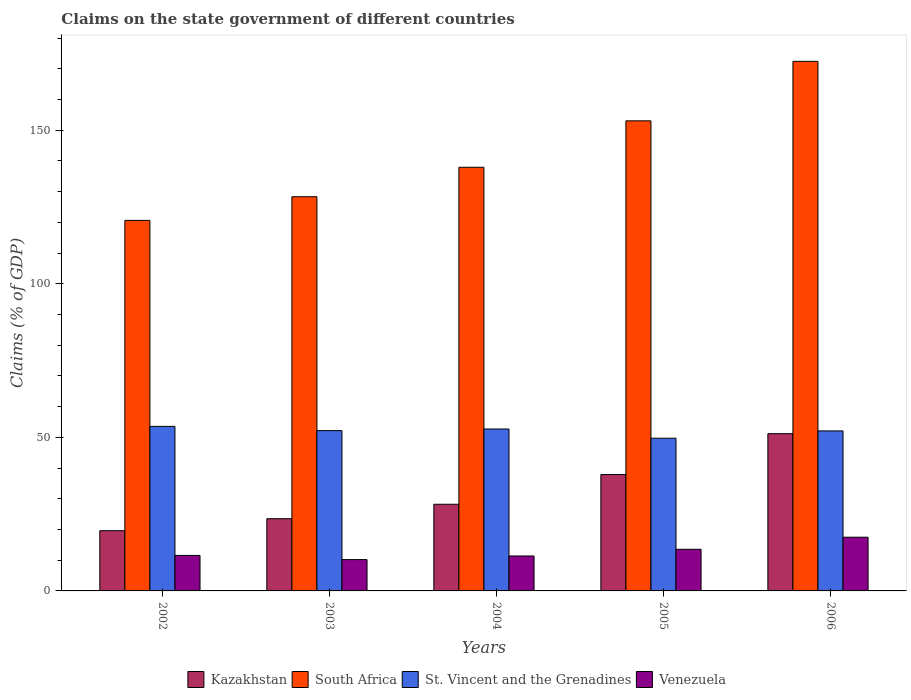How many different coloured bars are there?
Your answer should be compact. 4. Are the number of bars per tick equal to the number of legend labels?
Your answer should be compact. Yes. How many bars are there on the 1st tick from the left?
Make the answer very short. 4. What is the percentage of GDP claimed on the state government in Kazakhstan in 2002?
Make the answer very short. 19.61. Across all years, what is the maximum percentage of GDP claimed on the state government in Venezuela?
Ensure brevity in your answer.  17.49. Across all years, what is the minimum percentage of GDP claimed on the state government in Venezuela?
Provide a short and direct response. 10.2. What is the total percentage of GDP claimed on the state government in Venezuela in the graph?
Provide a short and direct response. 64.17. What is the difference between the percentage of GDP claimed on the state government in Kazakhstan in 2004 and that in 2006?
Provide a short and direct response. -22.98. What is the difference between the percentage of GDP claimed on the state government in Venezuela in 2003 and the percentage of GDP claimed on the state government in St. Vincent and the Grenadines in 2006?
Offer a very short reply. -41.9. What is the average percentage of GDP claimed on the state government in St. Vincent and the Grenadines per year?
Offer a terse response. 52.06. In the year 2005, what is the difference between the percentage of GDP claimed on the state government in Venezuela and percentage of GDP claimed on the state government in St. Vincent and the Grenadines?
Make the answer very short. -36.17. In how many years, is the percentage of GDP claimed on the state government in Venezuela greater than 10 %?
Give a very brief answer. 5. What is the ratio of the percentage of GDP claimed on the state government in South Africa in 2002 to that in 2005?
Give a very brief answer. 0.79. Is the percentage of GDP claimed on the state government in South Africa in 2004 less than that in 2006?
Provide a short and direct response. Yes. What is the difference between the highest and the second highest percentage of GDP claimed on the state government in Venezuela?
Give a very brief answer. 3.93. What is the difference between the highest and the lowest percentage of GDP claimed on the state government in Venezuela?
Keep it short and to the point. 7.29. In how many years, is the percentage of GDP claimed on the state government in Kazakhstan greater than the average percentage of GDP claimed on the state government in Kazakhstan taken over all years?
Your answer should be very brief. 2. What does the 2nd bar from the left in 2005 represents?
Provide a short and direct response. South Africa. What does the 1st bar from the right in 2003 represents?
Offer a very short reply. Venezuela. How many bars are there?
Keep it short and to the point. 20. Are the values on the major ticks of Y-axis written in scientific E-notation?
Offer a terse response. No. Does the graph contain any zero values?
Your answer should be very brief. No. Does the graph contain grids?
Give a very brief answer. No. What is the title of the graph?
Make the answer very short. Claims on the state government of different countries. Does "Mauritius" appear as one of the legend labels in the graph?
Keep it short and to the point. No. What is the label or title of the X-axis?
Your answer should be very brief. Years. What is the label or title of the Y-axis?
Give a very brief answer. Claims (% of GDP). What is the Claims (% of GDP) in Kazakhstan in 2002?
Provide a short and direct response. 19.61. What is the Claims (% of GDP) of South Africa in 2002?
Provide a succinct answer. 120.63. What is the Claims (% of GDP) in St. Vincent and the Grenadines in 2002?
Ensure brevity in your answer.  53.56. What is the Claims (% of GDP) in Venezuela in 2002?
Your response must be concise. 11.56. What is the Claims (% of GDP) of Kazakhstan in 2003?
Give a very brief answer. 23.51. What is the Claims (% of GDP) in South Africa in 2003?
Your answer should be compact. 128.34. What is the Claims (% of GDP) of St. Vincent and the Grenadines in 2003?
Give a very brief answer. 52.19. What is the Claims (% of GDP) in Venezuela in 2003?
Make the answer very short. 10.2. What is the Claims (% of GDP) of Kazakhstan in 2004?
Offer a terse response. 28.21. What is the Claims (% of GDP) of South Africa in 2004?
Keep it short and to the point. 137.93. What is the Claims (% of GDP) of St. Vincent and the Grenadines in 2004?
Offer a terse response. 52.72. What is the Claims (% of GDP) in Venezuela in 2004?
Provide a short and direct response. 11.38. What is the Claims (% of GDP) in Kazakhstan in 2005?
Provide a short and direct response. 37.89. What is the Claims (% of GDP) of South Africa in 2005?
Provide a short and direct response. 153.04. What is the Claims (% of GDP) of St. Vincent and the Grenadines in 2005?
Your response must be concise. 49.72. What is the Claims (% of GDP) in Venezuela in 2005?
Your answer should be very brief. 13.55. What is the Claims (% of GDP) in Kazakhstan in 2006?
Your answer should be very brief. 51.2. What is the Claims (% of GDP) in South Africa in 2006?
Offer a terse response. 172.41. What is the Claims (% of GDP) of St. Vincent and the Grenadines in 2006?
Your response must be concise. 52.09. What is the Claims (% of GDP) of Venezuela in 2006?
Provide a short and direct response. 17.49. Across all years, what is the maximum Claims (% of GDP) of Kazakhstan?
Provide a succinct answer. 51.2. Across all years, what is the maximum Claims (% of GDP) in South Africa?
Provide a succinct answer. 172.41. Across all years, what is the maximum Claims (% of GDP) in St. Vincent and the Grenadines?
Keep it short and to the point. 53.56. Across all years, what is the maximum Claims (% of GDP) of Venezuela?
Make the answer very short. 17.49. Across all years, what is the minimum Claims (% of GDP) in Kazakhstan?
Give a very brief answer. 19.61. Across all years, what is the minimum Claims (% of GDP) in South Africa?
Make the answer very short. 120.63. Across all years, what is the minimum Claims (% of GDP) in St. Vincent and the Grenadines?
Offer a terse response. 49.72. Across all years, what is the minimum Claims (% of GDP) in Venezuela?
Provide a succinct answer. 10.2. What is the total Claims (% of GDP) of Kazakhstan in the graph?
Give a very brief answer. 160.42. What is the total Claims (% of GDP) in South Africa in the graph?
Make the answer very short. 712.35. What is the total Claims (% of GDP) of St. Vincent and the Grenadines in the graph?
Give a very brief answer. 260.28. What is the total Claims (% of GDP) in Venezuela in the graph?
Your answer should be compact. 64.17. What is the difference between the Claims (% of GDP) in Kazakhstan in 2002 and that in 2003?
Ensure brevity in your answer.  -3.9. What is the difference between the Claims (% of GDP) in South Africa in 2002 and that in 2003?
Offer a very short reply. -7.7. What is the difference between the Claims (% of GDP) of St. Vincent and the Grenadines in 2002 and that in 2003?
Give a very brief answer. 1.37. What is the difference between the Claims (% of GDP) in Venezuela in 2002 and that in 2003?
Make the answer very short. 1.36. What is the difference between the Claims (% of GDP) in Kazakhstan in 2002 and that in 2004?
Provide a succinct answer. -8.61. What is the difference between the Claims (% of GDP) of South Africa in 2002 and that in 2004?
Offer a terse response. -17.29. What is the difference between the Claims (% of GDP) in St. Vincent and the Grenadines in 2002 and that in 2004?
Offer a very short reply. 0.84. What is the difference between the Claims (% of GDP) of Venezuela in 2002 and that in 2004?
Give a very brief answer. 0.18. What is the difference between the Claims (% of GDP) of Kazakhstan in 2002 and that in 2005?
Provide a succinct answer. -18.28. What is the difference between the Claims (% of GDP) of South Africa in 2002 and that in 2005?
Make the answer very short. -32.41. What is the difference between the Claims (% of GDP) in St. Vincent and the Grenadines in 2002 and that in 2005?
Your response must be concise. 3.84. What is the difference between the Claims (% of GDP) of Venezuela in 2002 and that in 2005?
Offer a very short reply. -2. What is the difference between the Claims (% of GDP) of Kazakhstan in 2002 and that in 2006?
Provide a succinct answer. -31.59. What is the difference between the Claims (% of GDP) in South Africa in 2002 and that in 2006?
Offer a terse response. -51.77. What is the difference between the Claims (% of GDP) in St. Vincent and the Grenadines in 2002 and that in 2006?
Provide a short and direct response. 1.47. What is the difference between the Claims (% of GDP) of Venezuela in 2002 and that in 2006?
Offer a terse response. -5.93. What is the difference between the Claims (% of GDP) of Kazakhstan in 2003 and that in 2004?
Provide a succinct answer. -4.7. What is the difference between the Claims (% of GDP) of South Africa in 2003 and that in 2004?
Make the answer very short. -9.59. What is the difference between the Claims (% of GDP) in St. Vincent and the Grenadines in 2003 and that in 2004?
Keep it short and to the point. -0.53. What is the difference between the Claims (% of GDP) of Venezuela in 2003 and that in 2004?
Your answer should be compact. -1.18. What is the difference between the Claims (% of GDP) in Kazakhstan in 2003 and that in 2005?
Your answer should be very brief. -14.38. What is the difference between the Claims (% of GDP) in South Africa in 2003 and that in 2005?
Make the answer very short. -24.7. What is the difference between the Claims (% of GDP) of St. Vincent and the Grenadines in 2003 and that in 2005?
Your answer should be compact. 2.47. What is the difference between the Claims (% of GDP) of Venezuela in 2003 and that in 2005?
Your response must be concise. -3.36. What is the difference between the Claims (% of GDP) of Kazakhstan in 2003 and that in 2006?
Offer a very short reply. -27.69. What is the difference between the Claims (% of GDP) of South Africa in 2003 and that in 2006?
Keep it short and to the point. -44.07. What is the difference between the Claims (% of GDP) of St. Vincent and the Grenadines in 2003 and that in 2006?
Offer a terse response. 0.1. What is the difference between the Claims (% of GDP) in Venezuela in 2003 and that in 2006?
Provide a short and direct response. -7.29. What is the difference between the Claims (% of GDP) of Kazakhstan in 2004 and that in 2005?
Offer a very short reply. -9.67. What is the difference between the Claims (% of GDP) of South Africa in 2004 and that in 2005?
Make the answer very short. -15.12. What is the difference between the Claims (% of GDP) of St. Vincent and the Grenadines in 2004 and that in 2005?
Provide a succinct answer. 3. What is the difference between the Claims (% of GDP) in Venezuela in 2004 and that in 2005?
Offer a terse response. -2.18. What is the difference between the Claims (% of GDP) of Kazakhstan in 2004 and that in 2006?
Make the answer very short. -22.98. What is the difference between the Claims (% of GDP) of South Africa in 2004 and that in 2006?
Offer a terse response. -34.48. What is the difference between the Claims (% of GDP) of St. Vincent and the Grenadines in 2004 and that in 2006?
Give a very brief answer. 0.63. What is the difference between the Claims (% of GDP) in Venezuela in 2004 and that in 2006?
Give a very brief answer. -6.11. What is the difference between the Claims (% of GDP) of Kazakhstan in 2005 and that in 2006?
Ensure brevity in your answer.  -13.31. What is the difference between the Claims (% of GDP) in South Africa in 2005 and that in 2006?
Make the answer very short. -19.37. What is the difference between the Claims (% of GDP) of St. Vincent and the Grenadines in 2005 and that in 2006?
Ensure brevity in your answer.  -2.37. What is the difference between the Claims (% of GDP) in Venezuela in 2005 and that in 2006?
Keep it short and to the point. -3.93. What is the difference between the Claims (% of GDP) in Kazakhstan in 2002 and the Claims (% of GDP) in South Africa in 2003?
Keep it short and to the point. -108.73. What is the difference between the Claims (% of GDP) of Kazakhstan in 2002 and the Claims (% of GDP) of St. Vincent and the Grenadines in 2003?
Offer a terse response. -32.58. What is the difference between the Claims (% of GDP) of Kazakhstan in 2002 and the Claims (% of GDP) of Venezuela in 2003?
Your response must be concise. 9.41. What is the difference between the Claims (% of GDP) in South Africa in 2002 and the Claims (% of GDP) in St. Vincent and the Grenadines in 2003?
Ensure brevity in your answer.  68.44. What is the difference between the Claims (% of GDP) of South Africa in 2002 and the Claims (% of GDP) of Venezuela in 2003?
Ensure brevity in your answer.  110.44. What is the difference between the Claims (% of GDP) in St. Vincent and the Grenadines in 2002 and the Claims (% of GDP) in Venezuela in 2003?
Provide a succinct answer. 43.37. What is the difference between the Claims (% of GDP) in Kazakhstan in 2002 and the Claims (% of GDP) in South Africa in 2004?
Give a very brief answer. -118.32. What is the difference between the Claims (% of GDP) of Kazakhstan in 2002 and the Claims (% of GDP) of St. Vincent and the Grenadines in 2004?
Your answer should be very brief. -33.11. What is the difference between the Claims (% of GDP) of Kazakhstan in 2002 and the Claims (% of GDP) of Venezuela in 2004?
Ensure brevity in your answer.  8.23. What is the difference between the Claims (% of GDP) of South Africa in 2002 and the Claims (% of GDP) of St. Vincent and the Grenadines in 2004?
Keep it short and to the point. 67.92. What is the difference between the Claims (% of GDP) of South Africa in 2002 and the Claims (% of GDP) of Venezuela in 2004?
Provide a succinct answer. 109.26. What is the difference between the Claims (% of GDP) in St. Vincent and the Grenadines in 2002 and the Claims (% of GDP) in Venezuela in 2004?
Give a very brief answer. 42.19. What is the difference between the Claims (% of GDP) of Kazakhstan in 2002 and the Claims (% of GDP) of South Africa in 2005?
Provide a succinct answer. -133.43. What is the difference between the Claims (% of GDP) in Kazakhstan in 2002 and the Claims (% of GDP) in St. Vincent and the Grenadines in 2005?
Keep it short and to the point. -30.11. What is the difference between the Claims (% of GDP) of Kazakhstan in 2002 and the Claims (% of GDP) of Venezuela in 2005?
Your answer should be very brief. 6.06. What is the difference between the Claims (% of GDP) of South Africa in 2002 and the Claims (% of GDP) of St. Vincent and the Grenadines in 2005?
Provide a succinct answer. 70.92. What is the difference between the Claims (% of GDP) of South Africa in 2002 and the Claims (% of GDP) of Venezuela in 2005?
Your answer should be compact. 107.08. What is the difference between the Claims (% of GDP) of St. Vincent and the Grenadines in 2002 and the Claims (% of GDP) of Venezuela in 2005?
Provide a succinct answer. 40.01. What is the difference between the Claims (% of GDP) in Kazakhstan in 2002 and the Claims (% of GDP) in South Africa in 2006?
Keep it short and to the point. -152.8. What is the difference between the Claims (% of GDP) of Kazakhstan in 2002 and the Claims (% of GDP) of St. Vincent and the Grenadines in 2006?
Your response must be concise. -32.48. What is the difference between the Claims (% of GDP) in Kazakhstan in 2002 and the Claims (% of GDP) in Venezuela in 2006?
Keep it short and to the point. 2.12. What is the difference between the Claims (% of GDP) of South Africa in 2002 and the Claims (% of GDP) of St. Vincent and the Grenadines in 2006?
Your response must be concise. 68.54. What is the difference between the Claims (% of GDP) in South Africa in 2002 and the Claims (% of GDP) in Venezuela in 2006?
Provide a succinct answer. 103.15. What is the difference between the Claims (% of GDP) of St. Vincent and the Grenadines in 2002 and the Claims (% of GDP) of Venezuela in 2006?
Your response must be concise. 36.07. What is the difference between the Claims (% of GDP) of Kazakhstan in 2003 and the Claims (% of GDP) of South Africa in 2004?
Offer a very short reply. -114.41. What is the difference between the Claims (% of GDP) in Kazakhstan in 2003 and the Claims (% of GDP) in St. Vincent and the Grenadines in 2004?
Keep it short and to the point. -29.21. What is the difference between the Claims (% of GDP) in Kazakhstan in 2003 and the Claims (% of GDP) in Venezuela in 2004?
Offer a terse response. 12.14. What is the difference between the Claims (% of GDP) in South Africa in 2003 and the Claims (% of GDP) in St. Vincent and the Grenadines in 2004?
Give a very brief answer. 75.62. What is the difference between the Claims (% of GDP) of South Africa in 2003 and the Claims (% of GDP) of Venezuela in 2004?
Your answer should be very brief. 116.96. What is the difference between the Claims (% of GDP) of St. Vincent and the Grenadines in 2003 and the Claims (% of GDP) of Venezuela in 2004?
Keep it short and to the point. 40.82. What is the difference between the Claims (% of GDP) in Kazakhstan in 2003 and the Claims (% of GDP) in South Africa in 2005?
Your answer should be compact. -129.53. What is the difference between the Claims (% of GDP) of Kazakhstan in 2003 and the Claims (% of GDP) of St. Vincent and the Grenadines in 2005?
Your answer should be compact. -26.21. What is the difference between the Claims (% of GDP) of Kazakhstan in 2003 and the Claims (% of GDP) of Venezuela in 2005?
Your answer should be very brief. 9.96. What is the difference between the Claims (% of GDP) in South Africa in 2003 and the Claims (% of GDP) in St. Vincent and the Grenadines in 2005?
Offer a terse response. 78.62. What is the difference between the Claims (% of GDP) in South Africa in 2003 and the Claims (% of GDP) in Venezuela in 2005?
Give a very brief answer. 114.79. What is the difference between the Claims (% of GDP) of St. Vincent and the Grenadines in 2003 and the Claims (% of GDP) of Venezuela in 2005?
Offer a very short reply. 38.64. What is the difference between the Claims (% of GDP) in Kazakhstan in 2003 and the Claims (% of GDP) in South Africa in 2006?
Keep it short and to the point. -148.9. What is the difference between the Claims (% of GDP) in Kazakhstan in 2003 and the Claims (% of GDP) in St. Vincent and the Grenadines in 2006?
Make the answer very short. -28.58. What is the difference between the Claims (% of GDP) of Kazakhstan in 2003 and the Claims (% of GDP) of Venezuela in 2006?
Provide a short and direct response. 6.02. What is the difference between the Claims (% of GDP) of South Africa in 2003 and the Claims (% of GDP) of St. Vincent and the Grenadines in 2006?
Keep it short and to the point. 76.25. What is the difference between the Claims (% of GDP) in South Africa in 2003 and the Claims (% of GDP) in Venezuela in 2006?
Offer a terse response. 110.85. What is the difference between the Claims (% of GDP) of St. Vincent and the Grenadines in 2003 and the Claims (% of GDP) of Venezuela in 2006?
Offer a very short reply. 34.7. What is the difference between the Claims (% of GDP) of Kazakhstan in 2004 and the Claims (% of GDP) of South Africa in 2005?
Offer a very short reply. -124.83. What is the difference between the Claims (% of GDP) of Kazakhstan in 2004 and the Claims (% of GDP) of St. Vincent and the Grenadines in 2005?
Keep it short and to the point. -21.5. What is the difference between the Claims (% of GDP) of Kazakhstan in 2004 and the Claims (% of GDP) of Venezuela in 2005?
Give a very brief answer. 14.66. What is the difference between the Claims (% of GDP) in South Africa in 2004 and the Claims (% of GDP) in St. Vincent and the Grenadines in 2005?
Keep it short and to the point. 88.21. What is the difference between the Claims (% of GDP) in South Africa in 2004 and the Claims (% of GDP) in Venezuela in 2005?
Provide a succinct answer. 124.37. What is the difference between the Claims (% of GDP) in St. Vincent and the Grenadines in 2004 and the Claims (% of GDP) in Venezuela in 2005?
Ensure brevity in your answer.  39.17. What is the difference between the Claims (% of GDP) in Kazakhstan in 2004 and the Claims (% of GDP) in South Africa in 2006?
Your answer should be very brief. -144.19. What is the difference between the Claims (% of GDP) in Kazakhstan in 2004 and the Claims (% of GDP) in St. Vincent and the Grenadines in 2006?
Ensure brevity in your answer.  -23.88. What is the difference between the Claims (% of GDP) of Kazakhstan in 2004 and the Claims (% of GDP) of Venezuela in 2006?
Ensure brevity in your answer.  10.73. What is the difference between the Claims (% of GDP) of South Africa in 2004 and the Claims (% of GDP) of St. Vincent and the Grenadines in 2006?
Provide a succinct answer. 85.83. What is the difference between the Claims (% of GDP) of South Africa in 2004 and the Claims (% of GDP) of Venezuela in 2006?
Provide a succinct answer. 120.44. What is the difference between the Claims (% of GDP) of St. Vincent and the Grenadines in 2004 and the Claims (% of GDP) of Venezuela in 2006?
Keep it short and to the point. 35.23. What is the difference between the Claims (% of GDP) in Kazakhstan in 2005 and the Claims (% of GDP) in South Africa in 2006?
Your answer should be compact. -134.52. What is the difference between the Claims (% of GDP) of Kazakhstan in 2005 and the Claims (% of GDP) of St. Vincent and the Grenadines in 2006?
Offer a very short reply. -14.21. What is the difference between the Claims (% of GDP) of Kazakhstan in 2005 and the Claims (% of GDP) of Venezuela in 2006?
Offer a terse response. 20.4. What is the difference between the Claims (% of GDP) of South Africa in 2005 and the Claims (% of GDP) of St. Vincent and the Grenadines in 2006?
Your response must be concise. 100.95. What is the difference between the Claims (% of GDP) in South Africa in 2005 and the Claims (% of GDP) in Venezuela in 2006?
Provide a short and direct response. 135.56. What is the difference between the Claims (% of GDP) in St. Vincent and the Grenadines in 2005 and the Claims (% of GDP) in Venezuela in 2006?
Keep it short and to the point. 32.23. What is the average Claims (% of GDP) of Kazakhstan per year?
Make the answer very short. 32.08. What is the average Claims (% of GDP) in South Africa per year?
Provide a succinct answer. 142.47. What is the average Claims (% of GDP) in St. Vincent and the Grenadines per year?
Your answer should be very brief. 52.06. What is the average Claims (% of GDP) of Venezuela per year?
Your answer should be compact. 12.83. In the year 2002, what is the difference between the Claims (% of GDP) of Kazakhstan and Claims (% of GDP) of South Africa?
Offer a terse response. -101.03. In the year 2002, what is the difference between the Claims (% of GDP) of Kazakhstan and Claims (% of GDP) of St. Vincent and the Grenadines?
Your answer should be very brief. -33.95. In the year 2002, what is the difference between the Claims (% of GDP) in Kazakhstan and Claims (% of GDP) in Venezuela?
Your answer should be very brief. 8.05. In the year 2002, what is the difference between the Claims (% of GDP) of South Africa and Claims (% of GDP) of St. Vincent and the Grenadines?
Give a very brief answer. 67.07. In the year 2002, what is the difference between the Claims (% of GDP) of South Africa and Claims (% of GDP) of Venezuela?
Your answer should be compact. 109.08. In the year 2002, what is the difference between the Claims (% of GDP) in St. Vincent and the Grenadines and Claims (% of GDP) in Venezuela?
Your answer should be very brief. 42. In the year 2003, what is the difference between the Claims (% of GDP) in Kazakhstan and Claims (% of GDP) in South Africa?
Keep it short and to the point. -104.83. In the year 2003, what is the difference between the Claims (% of GDP) in Kazakhstan and Claims (% of GDP) in St. Vincent and the Grenadines?
Provide a succinct answer. -28.68. In the year 2003, what is the difference between the Claims (% of GDP) of Kazakhstan and Claims (% of GDP) of Venezuela?
Your response must be concise. 13.32. In the year 2003, what is the difference between the Claims (% of GDP) in South Africa and Claims (% of GDP) in St. Vincent and the Grenadines?
Your answer should be very brief. 76.15. In the year 2003, what is the difference between the Claims (% of GDP) in South Africa and Claims (% of GDP) in Venezuela?
Provide a short and direct response. 118.14. In the year 2003, what is the difference between the Claims (% of GDP) of St. Vincent and the Grenadines and Claims (% of GDP) of Venezuela?
Make the answer very short. 42. In the year 2004, what is the difference between the Claims (% of GDP) in Kazakhstan and Claims (% of GDP) in South Africa?
Your response must be concise. -109.71. In the year 2004, what is the difference between the Claims (% of GDP) of Kazakhstan and Claims (% of GDP) of St. Vincent and the Grenadines?
Make the answer very short. -24.5. In the year 2004, what is the difference between the Claims (% of GDP) of Kazakhstan and Claims (% of GDP) of Venezuela?
Your answer should be compact. 16.84. In the year 2004, what is the difference between the Claims (% of GDP) in South Africa and Claims (% of GDP) in St. Vincent and the Grenadines?
Provide a succinct answer. 85.21. In the year 2004, what is the difference between the Claims (% of GDP) in South Africa and Claims (% of GDP) in Venezuela?
Offer a very short reply. 126.55. In the year 2004, what is the difference between the Claims (% of GDP) in St. Vincent and the Grenadines and Claims (% of GDP) in Venezuela?
Keep it short and to the point. 41.34. In the year 2005, what is the difference between the Claims (% of GDP) of Kazakhstan and Claims (% of GDP) of South Africa?
Your answer should be compact. -115.16. In the year 2005, what is the difference between the Claims (% of GDP) in Kazakhstan and Claims (% of GDP) in St. Vincent and the Grenadines?
Keep it short and to the point. -11.83. In the year 2005, what is the difference between the Claims (% of GDP) in Kazakhstan and Claims (% of GDP) in Venezuela?
Your answer should be compact. 24.34. In the year 2005, what is the difference between the Claims (% of GDP) in South Africa and Claims (% of GDP) in St. Vincent and the Grenadines?
Offer a terse response. 103.32. In the year 2005, what is the difference between the Claims (% of GDP) of South Africa and Claims (% of GDP) of Venezuela?
Your answer should be compact. 139.49. In the year 2005, what is the difference between the Claims (% of GDP) in St. Vincent and the Grenadines and Claims (% of GDP) in Venezuela?
Your answer should be compact. 36.17. In the year 2006, what is the difference between the Claims (% of GDP) of Kazakhstan and Claims (% of GDP) of South Africa?
Your answer should be compact. -121.21. In the year 2006, what is the difference between the Claims (% of GDP) in Kazakhstan and Claims (% of GDP) in St. Vincent and the Grenadines?
Make the answer very short. -0.89. In the year 2006, what is the difference between the Claims (% of GDP) of Kazakhstan and Claims (% of GDP) of Venezuela?
Keep it short and to the point. 33.71. In the year 2006, what is the difference between the Claims (% of GDP) in South Africa and Claims (% of GDP) in St. Vincent and the Grenadines?
Ensure brevity in your answer.  120.32. In the year 2006, what is the difference between the Claims (% of GDP) of South Africa and Claims (% of GDP) of Venezuela?
Provide a succinct answer. 154.92. In the year 2006, what is the difference between the Claims (% of GDP) in St. Vincent and the Grenadines and Claims (% of GDP) in Venezuela?
Your answer should be very brief. 34.61. What is the ratio of the Claims (% of GDP) in Kazakhstan in 2002 to that in 2003?
Provide a short and direct response. 0.83. What is the ratio of the Claims (% of GDP) of St. Vincent and the Grenadines in 2002 to that in 2003?
Make the answer very short. 1.03. What is the ratio of the Claims (% of GDP) in Venezuela in 2002 to that in 2003?
Provide a short and direct response. 1.13. What is the ratio of the Claims (% of GDP) in Kazakhstan in 2002 to that in 2004?
Give a very brief answer. 0.69. What is the ratio of the Claims (% of GDP) in South Africa in 2002 to that in 2004?
Your answer should be very brief. 0.87. What is the ratio of the Claims (% of GDP) of St. Vincent and the Grenadines in 2002 to that in 2004?
Ensure brevity in your answer.  1.02. What is the ratio of the Claims (% of GDP) of Venezuela in 2002 to that in 2004?
Your response must be concise. 1.02. What is the ratio of the Claims (% of GDP) in Kazakhstan in 2002 to that in 2005?
Provide a succinct answer. 0.52. What is the ratio of the Claims (% of GDP) in South Africa in 2002 to that in 2005?
Offer a very short reply. 0.79. What is the ratio of the Claims (% of GDP) in St. Vincent and the Grenadines in 2002 to that in 2005?
Offer a terse response. 1.08. What is the ratio of the Claims (% of GDP) in Venezuela in 2002 to that in 2005?
Your response must be concise. 0.85. What is the ratio of the Claims (% of GDP) in Kazakhstan in 2002 to that in 2006?
Give a very brief answer. 0.38. What is the ratio of the Claims (% of GDP) of South Africa in 2002 to that in 2006?
Provide a succinct answer. 0.7. What is the ratio of the Claims (% of GDP) of St. Vincent and the Grenadines in 2002 to that in 2006?
Offer a terse response. 1.03. What is the ratio of the Claims (% of GDP) in Venezuela in 2002 to that in 2006?
Your answer should be very brief. 0.66. What is the ratio of the Claims (% of GDP) of Kazakhstan in 2003 to that in 2004?
Your answer should be very brief. 0.83. What is the ratio of the Claims (% of GDP) of South Africa in 2003 to that in 2004?
Make the answer very short. 0.93. What is the ratio of the Claims (% of GDP) of St. Vincent and the Grenadines in 2003 to that in 2004?
Make the answer very short. 0.99. What is the ratio of the Claims (% of GDP) of Venezuela in 2003 to that in 2004?
Ensure brevity in your answer.  0.9. What is the ratio of the Claims (% of GDP) in Kazakhstan in 2003 to that in 2005?
Offer a terse response. 0.62. What is the ratio of the Claims (% of GDP) in South Africa in 2003 to that in 2005?
Ensure brevity in your answer.  0.84. What is the ratio of the Claims (% of GDP) in St. Vincent and the Grenadines in 2003 to that in 2005?
Your answer should be very brief. 1.05. What is the ratio of the Claims (% of GDP) in Venezuela in 2003 to that in 2005?
Your answer should be very brief. 0.75. What is the ratio of the Claims (% of GDP) in Kazakhstan in 2003 to that in 2006?
Offer a very short reply. 0.46. What is the ratio of the Claims (% of GDP) of South Africa in 2003 to that in 2006?
Give a very brief answer. 0.74. What is the ratio of the Claims (% of GDP) in St. Vincent and the Grenadines in 2003 to that in 2006?
Ensure brevity in your answer.  1. What is the ratio of the Claims (% of GDP) in Venezuela in 2003 to that in 2006?
Your response must be concise. 0.58. What is the ratio of the Claims (% of GDP) of Kazakhstan in 2004 to that in 2005?
Ensure brevity in your answer.  0.74. What is the ratio of the Claims (% of GDP) in South Africa in 2004 to that in 2005?
Offer a terse response. 0.9. What is the ratio of the Claims (% of GDP) of St. Vincent and the Grenadines in 2004 to that in 2005?
Give a very brief answer. 1.06. What is the ratio of the Claims (% of GDP) in Venezuela in 2004 to that in 2005?
Ensure brevity in your answer.  0.84. What is the ratio of the Claims (% of GDP) in Kazakhstan in 2004 to that in 2006?
Provide a succinct answer. 0.55. What is the ratio of the Claims (% of GDP) of South Africa in 2004 to that in 2006?
Ensure brevity in your answer.  0.8. What is the ratio of the Claims (% of GDP) of Venezuela in 2004 to that in 2006?
Make the answer very short. 0.65. What is the ratio of the Claims (% of GDP) in Kazakhstan in 2005 to that in 2006?
Your answer should be very brief. 0.74. What is the ratio of the Claims (% of GDP) of South Africa in 2005 to that in 2006?
Make the answer very short. 0.89. What is the ratio of the Claims (% of GDP) in St. Vincent and the Grenadines in 2005 to that in 2006?
Your response must be concise. 0.95. What is the ratio of the Claims (% of GDP) of Venezuela in 2005 to that in 2006?
Provide a short and direct response. 0.78. What is the difference between the highest and the second highest Claims (% of GDP) in Kazakhstan?
Your answer should be very brief. 13.31. What is the difference between the highest and the second highest Claims (% of GDP) in South Africa?
Your answer should be compact. 19.37. What is the difference between the highest and the second highest Claims (% of GDP) of St. Vincent and the Grenadines?
Provide a succinct answer. 0.84. What is the difference between the highest and the second highest Claims (% of GDP) in Venezuela?
Provide a succinct answer. 3.93. What is the difference between the highest and the lowest Claims (% of GDP) of Kazakhstan?
Give a very brief answer. 31.59. What is the difference between the highest and the lowest Claims (% of GDP) of South Africa?
Offer a terse response. 51.77. What is the difference between the highest and the lowest Claims (% of GDP) in St. Vincent and the Grenadines?
Make the answer very short. 3.84. What is the difference between the highest and the lowest Claims (% of GDP) in Venezuela?
Offer a terse response. 7.29. 